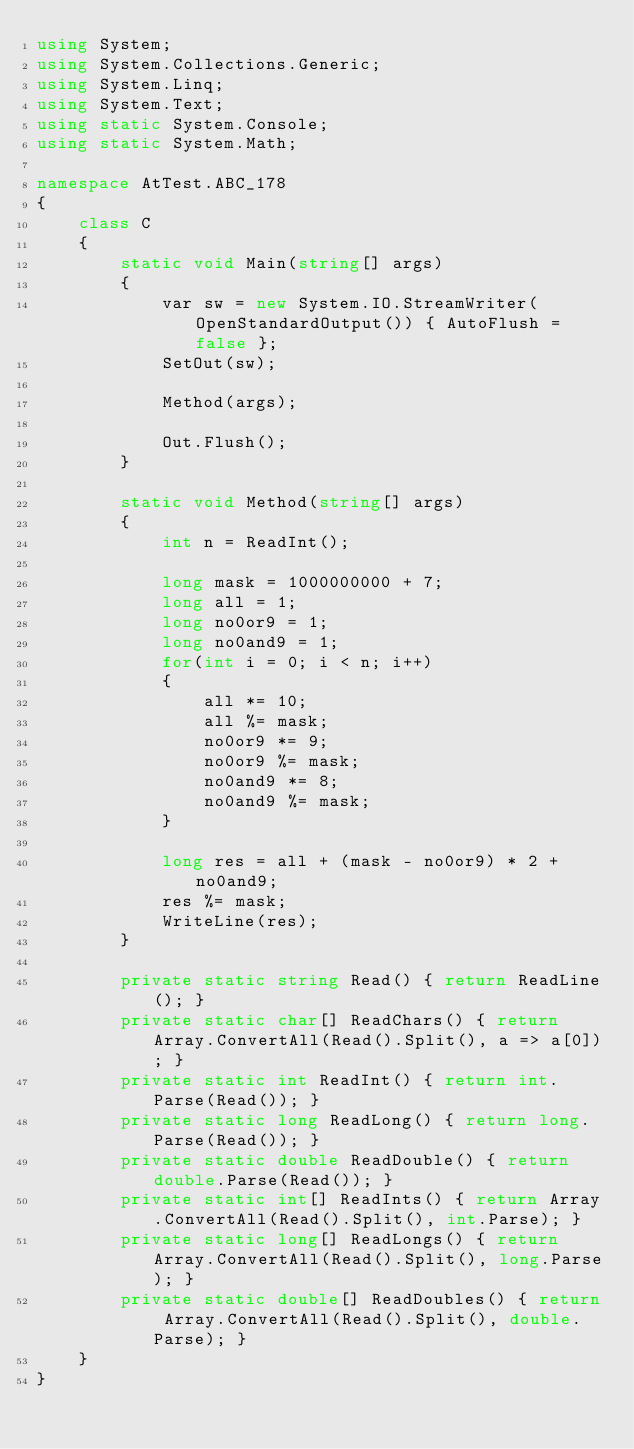Convert code to text. <code><loc_0><loc_0><loc_500><loc_500><_C#_>using System;
using System.Collections.Generic;
using System.Linq;
using System.Text;
using static System.Console;
using static System.Math;

namespace AtTest.ABC_178
{
    class C
    {
        static void Main(string[] args)
        {
            var sw = new System.IO.StreamWriter(OpenStandardOutput()) { AutoFlush = false };
            SetOut(sw);

            Method(args);

            Out.Flush();
        }

        static void Method(string[] args)
        {
            int n = ReadInt();

            long mask = 1000000000 + 7;
            long all = 1;
            long no0or9 = 1;
            long no0and9 = 1;
            for(int i = 0; i < n; i++)
            {
                all *= 10;
                all %= mask;
                no0or9 *= 9;
                no0or9 %= mask;
                no0and9 *= 8;
                no0and9 %= mask;
            }

            long res = all + (mask - no0or9) * 2 + no0and9;
            res %= mask;
            WriteLine(res);
        }

        private static string Read() { return ReadLine(); }
        private static char[] ReadChars() { return Array.ConvertAll(Read().Split(), a => a[0]); }
        private static int ReadInt() { return int.Parse(Read()); }
        private static long ReadLong() { return long.Parse(Read()); }
        private static double ReadDouble() { return double.Parse(Read()); }
        private static int[] ReadInts() { return Array.ConvertAll(Read().Split(), int.Parse); }
        private static long[] ReadLongs() { return Array.ConvertAll(Read().Split(), long.Parse); }
        private static double[] ReadDoubles() { return Array.ConvertAll(Read().Split(), double.Parse); }
    }
}
</code> 